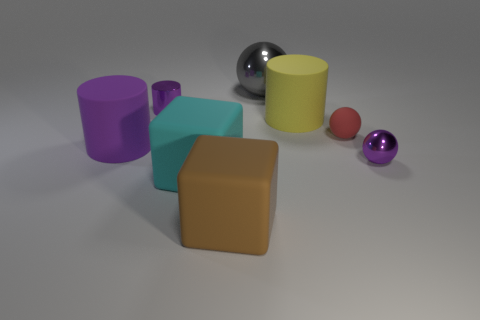Are there any other yellow matte things that have the same size as the yellow rubber thing?
Provide a succinct answer. No. How many things are big things or big blue shiny cubes?
Provide a short and direct response. 5. Do the metallic sphere that is in front of the gray shiny ball and the rubber cylinder on the right side of the gray shiny sphere have the same size?
Offer a very short reply. No. Are there any other matte objects that have the same shape as the tiny red thing?
Keep it short and to the point. No. Are there fewer gray shiny things to the left of the tiny cylinder than large matte cubes?
Offer a terse response. Yes. Is the shape of the big shiny thing the same as the small red matte thing?
Your answer should be compact. Yes. What is the size of the shiny sphere that is in front of the big yellow rubber thing?
Provide a short and direct response. Small. There is a purple sphere that is the same material as the tiny cylinder; what is its size?
Your response must be concise. Small. Are there fewer small matte things than small green matte objects?
Ensure brevity in your answer.  No. What material is the purple thing that is the same size as the purple metallic cylinder?
Your answer should be very brief. Metal. 